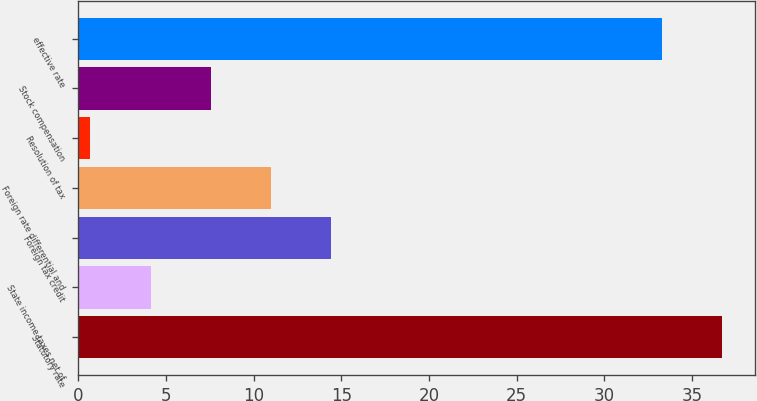Convert chart to OTSL. <chart><loc_0><loc_0><loc_500><loc_500><bar_chart><fcel>Statutory rate<fcel>State income taxes net of<fcel>Foreign tax credit<fcel>Foreign rate differential and<fcel>Resolution of tax<fcel>Stock compensation<fcel>effective rate<nl><fcel>36.73<fcel>4.13<fcel>14.42<fcel>10.99<fcel>0.7<fcel>7.56<fcel>33.3<nl></chart> 